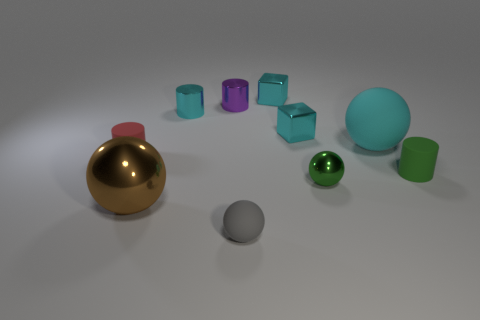There is a rubber object that is the same color as the tiny shiny sphere; what is its shape?
Your answer should be compact. Cylinder. Are there any other things that are the same material as the tiny gray object?
Your answer should be compact. Yes. Are there fewer small cyan blocks behind the small purple cylinder than large gray metallic spheres?
Your response must be concise. No. Is the number of small gray matte balls that are right of the large cyan thing greater than the number of small gray things behind the tiny red matte thing?
Provide a succinct answer. No. Are there any other things of the same color as the large shiny thing?
Give a very brief answer. No. There is a cyan object that is behind the small cyan shiny cylinder; what is it made of?
Provide a short and direct response. Metal. Do the gray rubber ball and the cyan cylinder have the same size?
Your answer should be compact. Yes. What number of other objects are there of the same size as the brown shiny ball?
Offer a very short reply. 1. Is the color of the large matte object the same as the large shiny ball?
Your answer should be very brief. No. The tiny rubber object to the left of the small ball left of the metal ball that is behind the big metallic ball is what shape?
Give a very brief answer. Cylinder. 